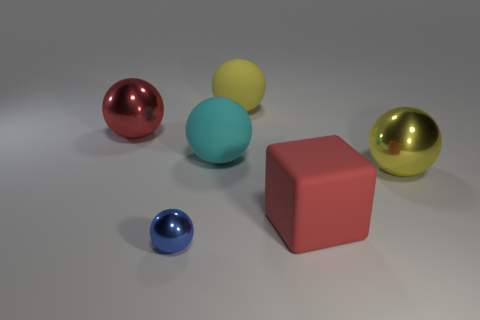What could be the size of the cube relative to the spheres? Based on the image, the cube's dimensions are larger than any of the spheres. It's difficult to provide an exact comparison without measurements, but it seems roughly twice the diameter of the largest sphere, likely making it the most prominent object in terms of volume. 